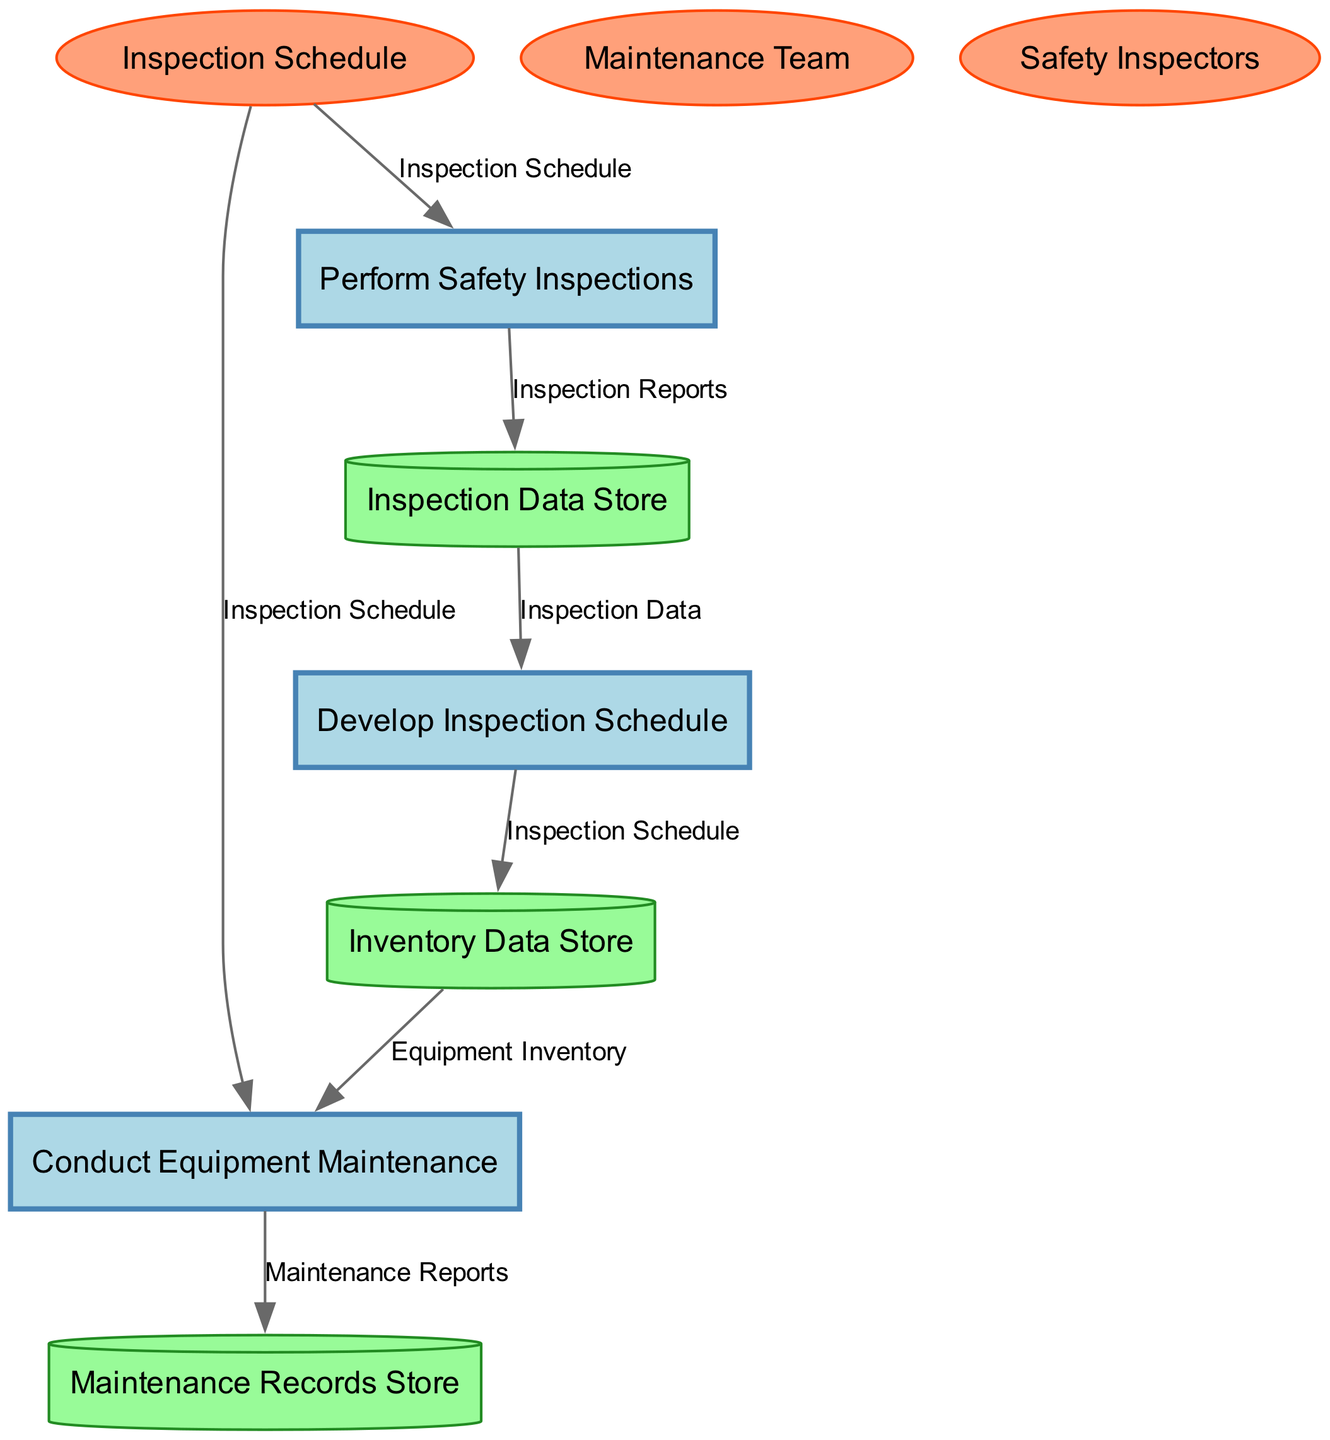What is the name of the first process? The first process listed in the diagram is "Develop Inspection Schedule." This answer is derived from identifying the processes section of the diagram where each process is labeled.
Answer: Develop Inspection Schedule How many data stores are in the diagram? There are three data stores shown in the diagram: "Inspection Data Store," "Maintenance Records Store," and "Inventory Data Store." Counting these yields a total of three data stores.
Answer: 3 Which entity outputs the "Maintenance Reports"? The external entity "Maintenance Team" outputs "Maintenance Reports." This is identified by examining the relationship between external entities and the outputs they provide.
Answer: Maintenance Team What is the input to the "Conduct Equipment Maintenance" process? The inputs to "Conduct Equipment Maintenance" are "Inspection Schedule" and "Maintenance Resources." These inputs are explicitly listed in the process details within the diagram.
Answer: Inspection Schedule, Maintenance Resources Which process receives input from both the "Inspection Schedule" and "Inspection Data Store"? The process "Perform Safety Inspections" receives input from both sources: "Inspection Schedule" and "Inspection Data Store." This can be seen by tracing the connections from both inputs to the process.
Answer: Perform Safety Inspections How does the "Inspection Schedule" reach the "Maintenance Records Store"? The "Inspection Schedule" first goes to "Conduct Equipment Maintenance," which generates "Maintenance Reports," and then these reports are sent to the "Maintenance Records Store." This involves following the flow from the "Inspection Schedule" through to the "Maintenance Records Store" as described in the data flow paths.
Answer: Through Conduct Equipment Maintenance What data flows from "Inspection Data Store" to "Develop Inspection Schedule"? The data flowing from "Inspection Data Store" to "Develop Inspection Schedule" is "Inspection Data." This is clearly outlined in the data flow connections starting from the data store to the process.
Answer: Inspection Data What type of diagram is represented? The diagram displayed is a Data Flow Diagram (DFD), identifiable by its structure of processes, data flows, data stores, and external entities, each communicating their relationships and data exchanges.
Answer: Data Flow Diagram How many processes are represented in the diagram? There are three processes represented in the diagram: "Develop Inspection Schedule," "Conduct Equipment Maintenance," and "Perform Safety Inspections." By listing each process, the total is determined to be three.
Answer: 3 What type of entity is "Safety Inspectors"? "Safety Inspectors" is classified as an external entity in the diagram, indicated by its shape (ellipse) used to represent external sources that interact with the internal system.
Answer: External entity 